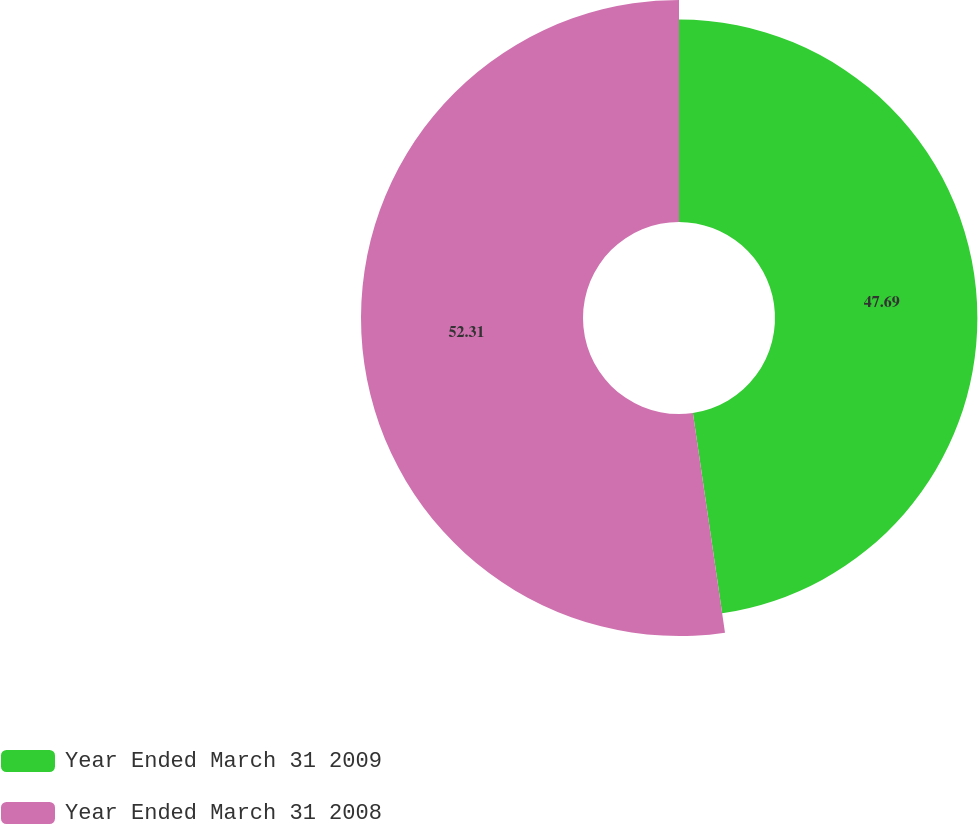Convert chart. <chart><loc_0><loc_0><loc_500><loc_500><pie_chart><fcel>Year Ended March 31 2009<fcel>Year Ended March 31 2008<nl><fcel>47.69%<fcel>52.31%<nl></chart> 